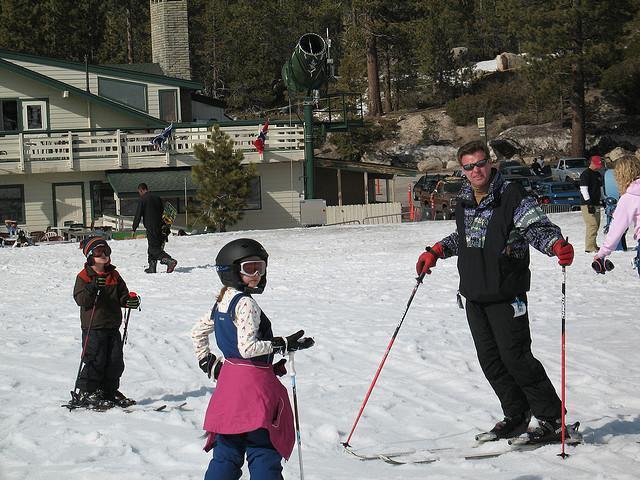What is the man in black behind the child walking away with?
Choose the right answer from the provided options to respond to the question.
Options: Jacket, backpack, snowboard, fence. Snowboard. 